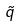Convert formula to latex. <formula><loc_0><loc_0><loc_500><loc_500>\tilde { q }</formula> 